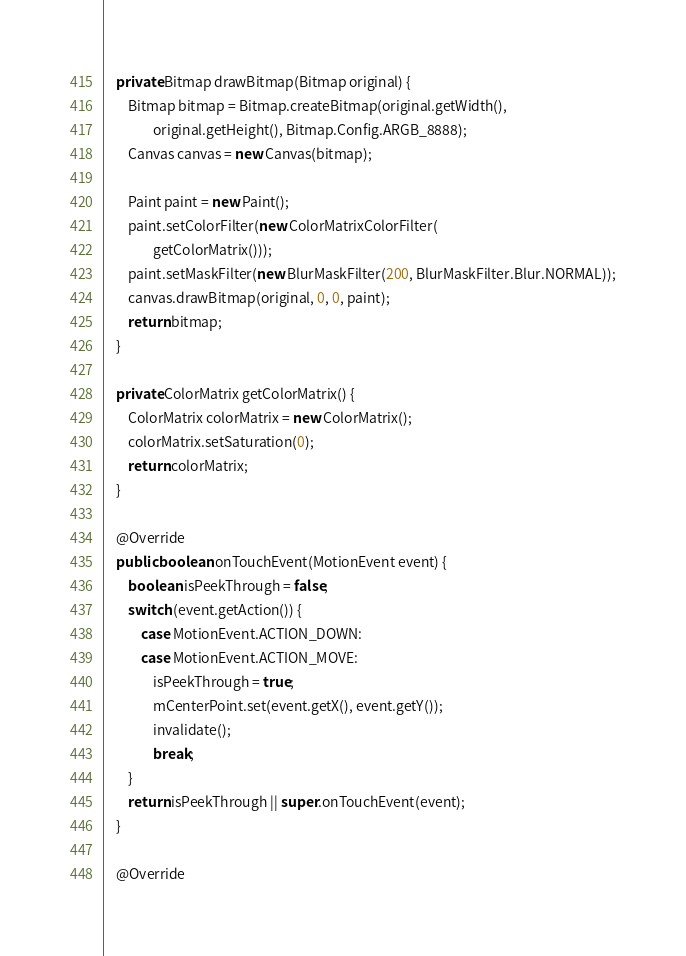Convert code to text. <code><loc_0><loc_0><loc_500><loc_500><_Java_>
    private Bitmap drawBitmap(Bitmap original) {
        Bitmap bitmap = Bitmap.createBitmap(original.getWidth(),
                original.getHeight(), Bitmap.Config.ARGB_8888);
        Canvas canvas = new Canvas(bitmap);

        Paint paint = new Paint();
        paint.setColorFilter(new ColorMatrixColorFilter(
                getColorMatrix()));
        paint.setMaskFilter(new BlurMaskFilter(200, BlurMaskFilter.Blur.NORMAL));
        canvas.drawBitmap(original, 0, 0, paint);
        return bitmap;
    }

    private ColorMatrix getColorMatrix() {
        ColorMatrix colorMatrix = new ColorMatrix();
        colorMatrix.setSaturation(0);
        return colorMatrix;
    }

    @Override
    public boolean onTouchEvent(MotionEvent event) {
        boolean isPeekThrough = false;
        switch (event.getAction()) {
            case MotionEvent.ACTION_DOWN:
            case MotionEvent.ACTION_MOVE:
                isPeekThrough = true;
                mCenterPoint.set(event.getX(), event.getY());
                invalidate();
                break;
        }
        return isPeekThrough || super.onTouchEvent(event);
    }

    @Override</code> 